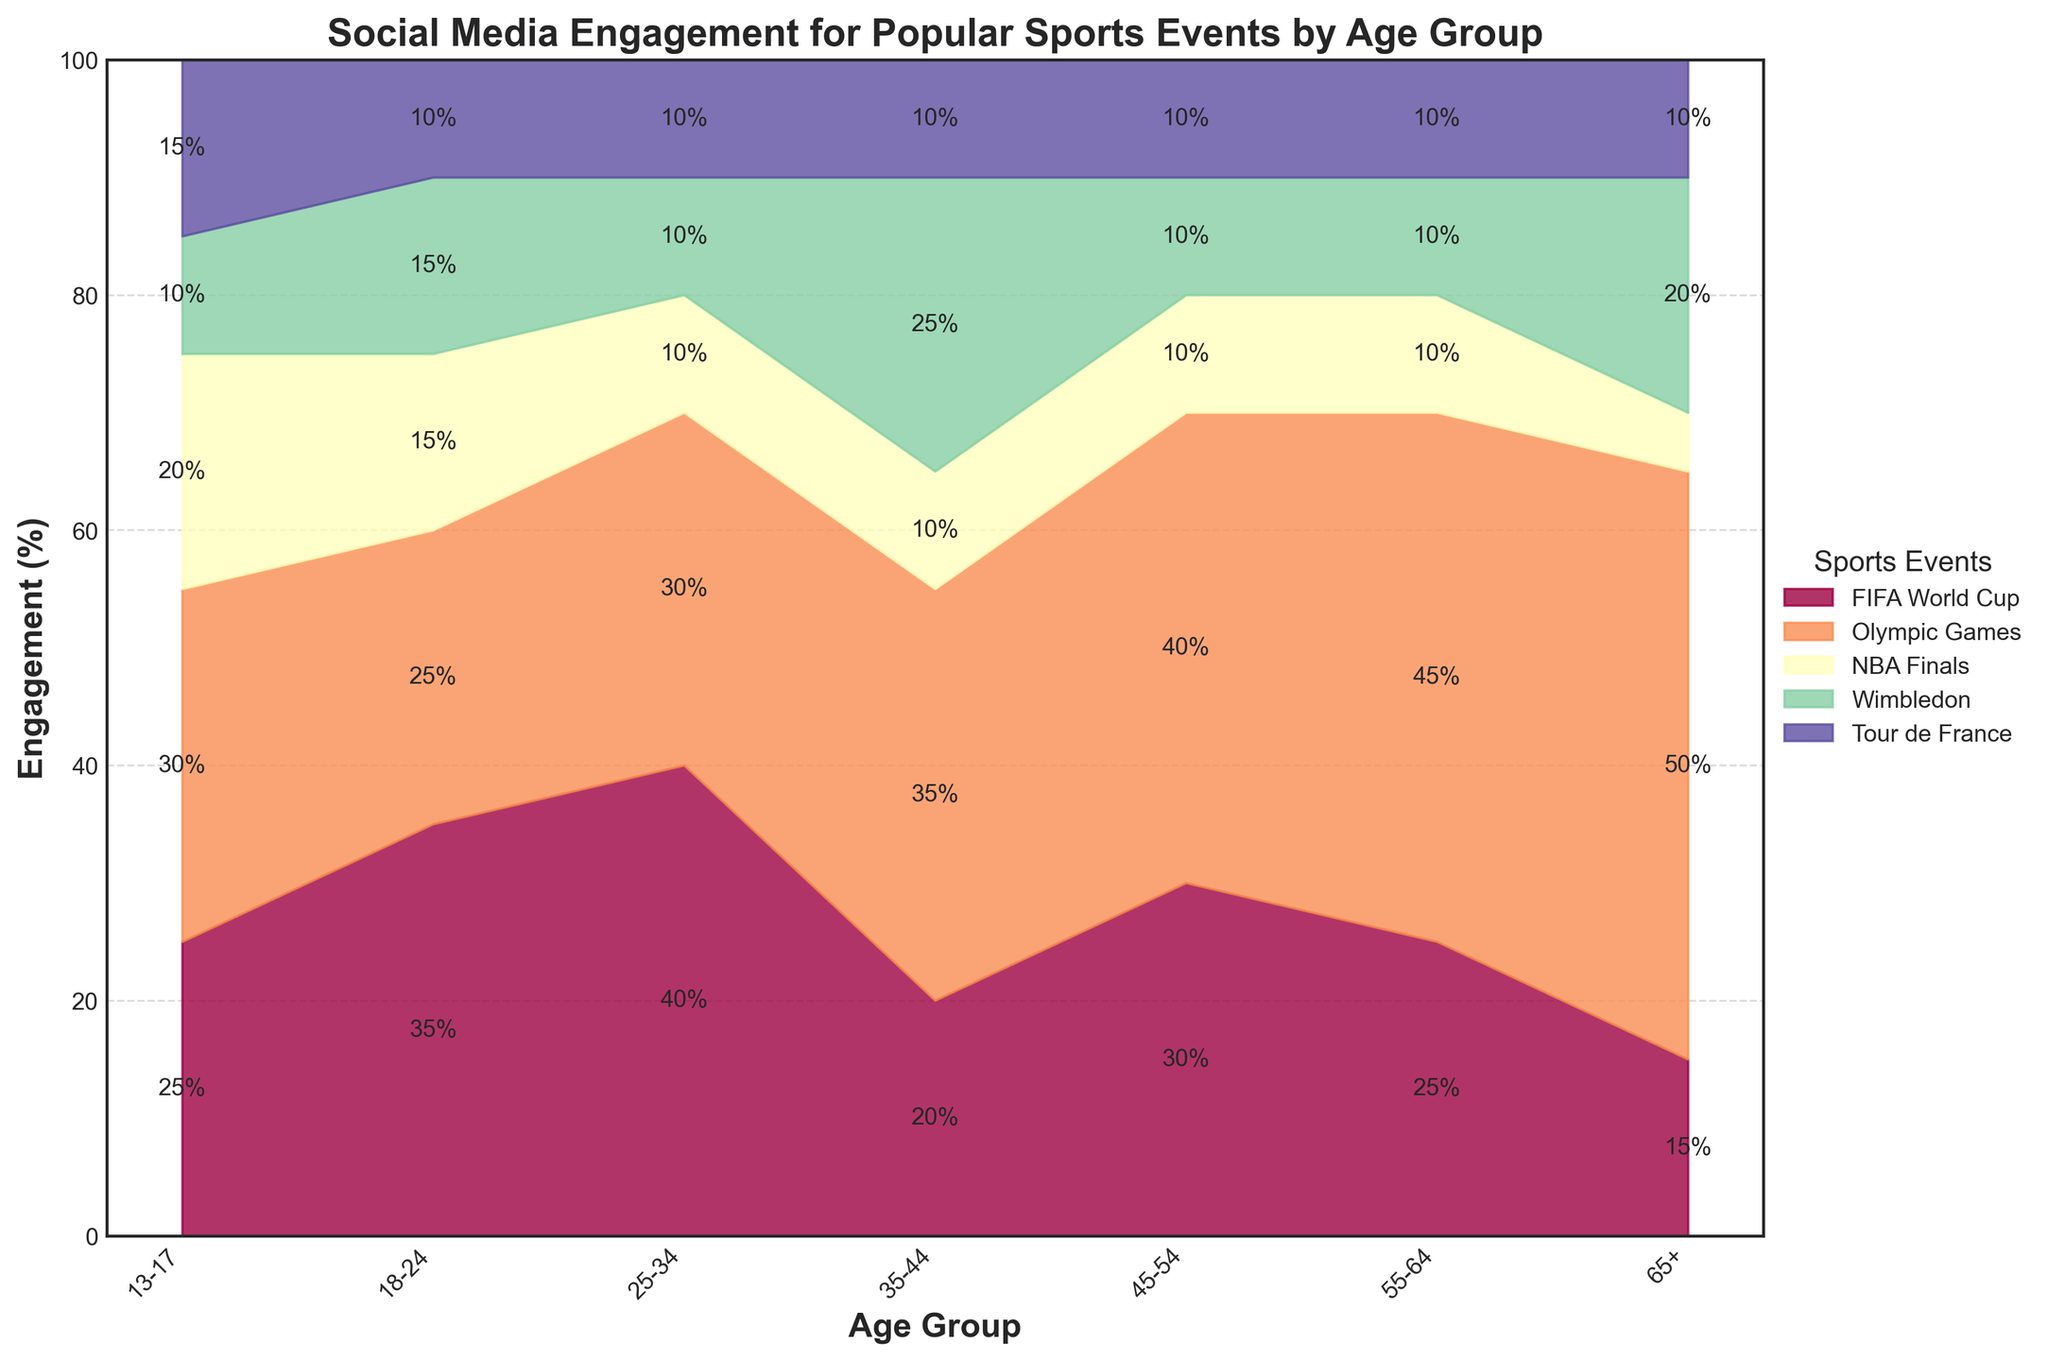What is the title of the chart? The title of the chart is typically located at the top center. It provides an overview of what the chart represents. In this case, the title reads: "Social Media Engagement for Popular Sports Events by Age Group."
Answer: Social Media Engagement for Popular Sports Events by Age Group How many age groups are represented in the chart? The age groups are displayed on the x-axis of the chart. By counting the distinct labels, we can determine the number of age groups.
Answer: 7 Which sports event has the highest engagement for the 65+ age group? For the 65+ age group, observe the section that has the highest vertical span in the area chart. The event with the largest segment indicates the highest engagement.
Answer: Olympic Games What is the engagement percentage of the FIFA World Cup for the 13-17 age group? For the 13-17 age group, look at the stacked area section representing the FIFA World Cup. The height of this section relative to the 100% scale indicates the percentage.
Answer: 25% Which sports event has the lowest engagement for the 18-24 age group on Twitter? For the 18-24 age group on Twitter, identify the segment with the smallest height in the stacked area chart. This event is the one with the least engagement.
Answer: Tour de France Compare the engagement rates for the Olympic Games between the 25-34 and 55-64 age groups. Which group has a higher rate? Locate the Olympic Games segments for both age groups. Compare the vertical spans of these segments to see which is higher.
Answer: 55-64 What is the engagement percentage difference for Wimbledon between the 35-44 and 45-54 age groups? Find the Wimbledon segments for both age groups. Subtract the engagement percentage of the 35-44 group from that of the 45-54 group to find the difference.
Answer: 0% What trend can you observe for the engagement in the NBA Finals across different age groups? Analyze the segments for the NBA Finals across all age groups to identify any patterns or trends, such as an increase or decrease in engagement.
Answer: Engagement generally decreases with age Which age group has the most diverse engagement across multiple sports events? Identify the age group that has segments of roughly equal heights for different events, indicating more diverse or evenly spread engagement.
Answer: 13-17 How does engagement in the FIFA World Cup compare between the 18-24 and 35-44 age groups? Compare the height of the FIFA World Cup segment for the 18-24 age group with that of the 35-44 age group to determine which is higher.
Answer: 18-24 